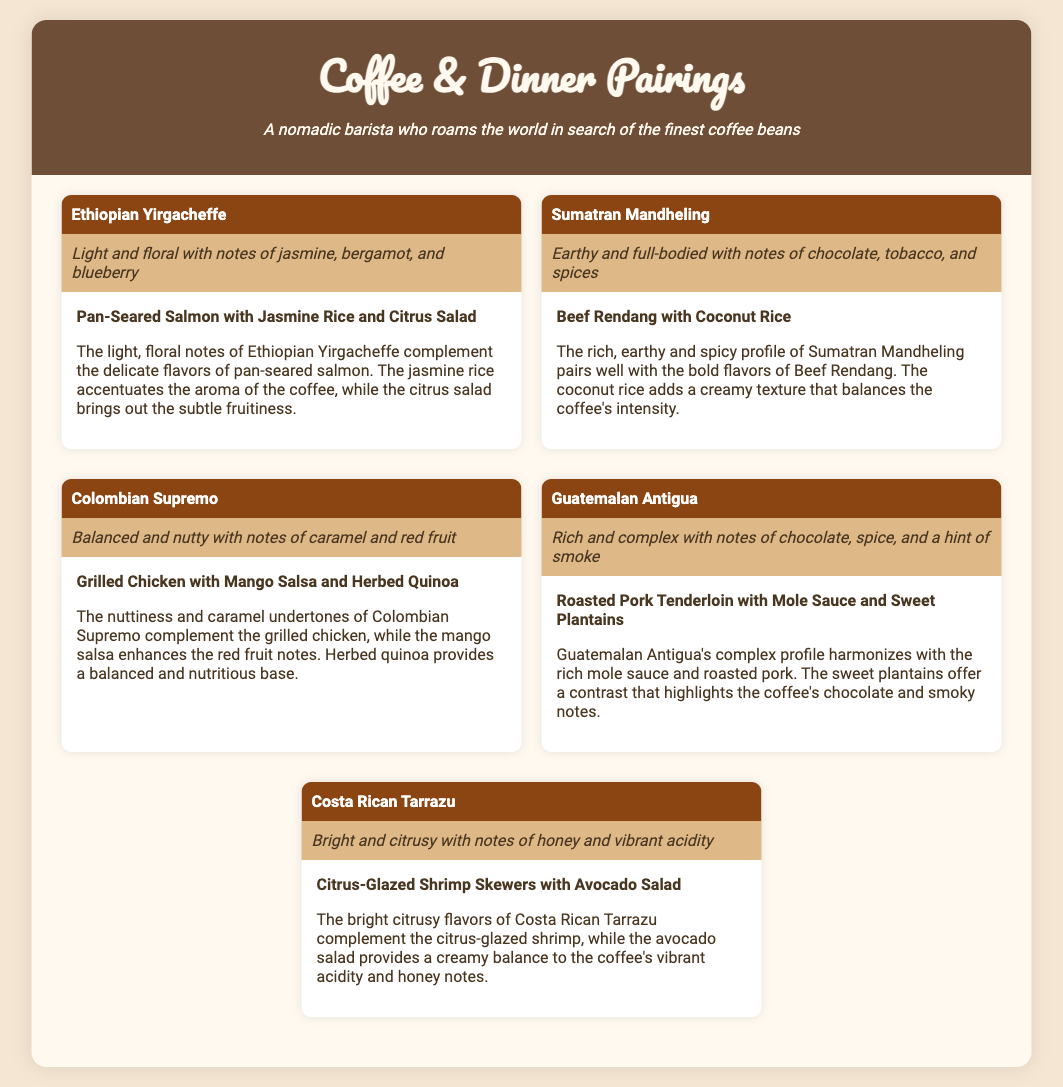What coffee type is paired with pan-seared salmon? The coffee type paired with pan-seared salmon is Ethiopian Yirgacheffe.
Answer: Ethiopian Yirgacheffe What is the main dish served with Sumatran Mandheling? The main dish served with Sumatran Mandheling is Beef Rendang with Coconut Rice.
Answer: Beef Rendang with Coconut Rice Which coffee has floral notes? Ethiopian Yirgacheffe is described as having light and floral notes.
Answer: Ethiopian Yirgacheffe What flavor characteristics does Guatemalan Antigua feature? Guatemalan Antigua features rich and complex notes of chocolate, spice, and a hint of smoke.
Answer: Chocolate, spice, and smoke What dish complements the bright flavors of Costa Rican Tarrazu? Citrus-Glazed Shrimp Skewers with Avocado Salad complement the bright flavors.
Answer: Citrus-Glazed Shrimp Skewers with Avocado Salad What is the flavor profile of Colombian Supremo? Colombian Supremo is balanced and nutty with notes of caramel and red fruit.
Answer: Balanced and nutty Which pairing offers a contrast to the chocolate notes? The sweet plantains offer a contrast that highlights the coffee's chocolate and smoky notes.
Answer: Sweet plantains How many coffee types are listed in the meal plan? There are five coffee types listed in the meal plan.
Answer: Five 